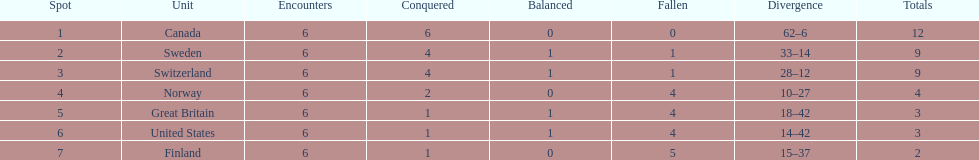During the 1951 world ice hockey championships, what was the difference between the first and last place teams for number of games won ? 5. 